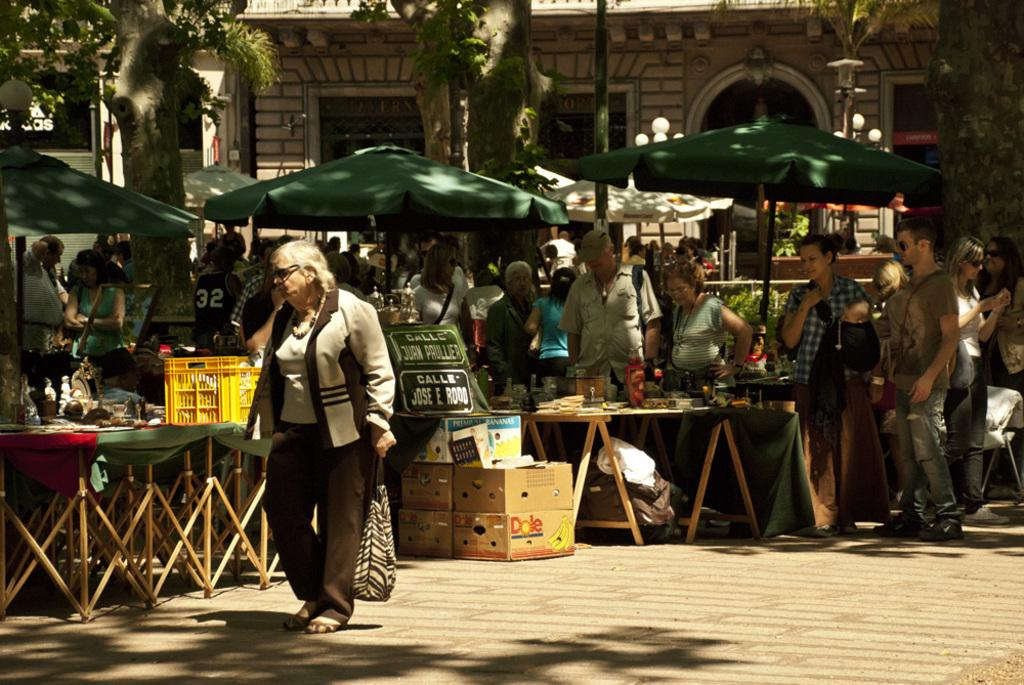<image>
Present a compact description of the photo's key features. Calle Jurn Pruller and Jose E Rodo are printed on a sign in front of the kiosks. 